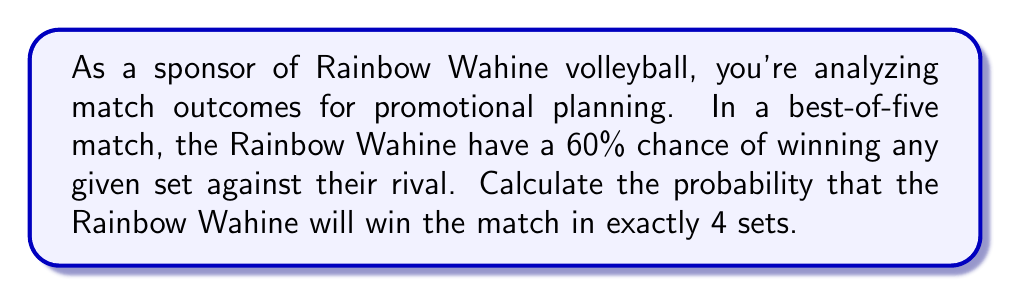What is the answer to this math problem? Let's approach this step-by-step:

1) For the match to be won in exactly 4 sets, the Rainbow Wahine must win 3 sets and lose 1 set, in any order except LWWW (as the match would end after 3 sets in this case).

2) The possible winning combinations are:
   WWWL, WWLW, WLWW

3) Let's define:
   $p$ = probability of winning a set = 0.60
   $q$ = probability of losing a set = 1 - p = 0.40

4) The probability of each specific combination is:
   $P(WWWL) = P(WWLW) = P(WLWW) = p^3 \cdot q^1$

5) We can calculate this as:
   $p^3 \cdot q^1 = 0.60^3 \cdot 0.40^1 = 0.0864$

6) Since there are 3 possible ways this can happen, we multiply by 3:
   $P(\text{win in exactly 4 sets}) = 3 \cdot (p^3 \cdot q^1)$

7) Calculating:
   $P(\text{win in exactly 4 sets}) = 3 \cdot 0.0864 = 0.2592$

Thus, the probability of the Rainbow Wahine winning the match in exactly 4 sets is 0.2592 or 25.92%.
Answer: 0.2592 or 25.92% 